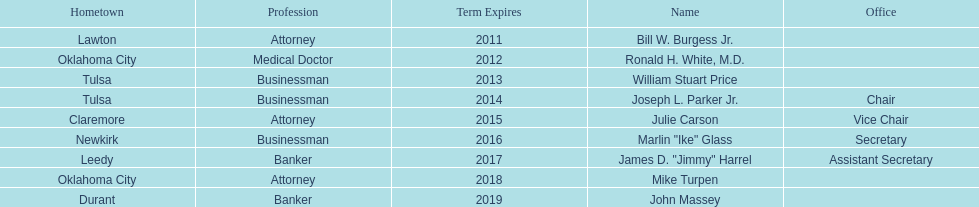Total number of members from lawton and oklahoma city 3. 